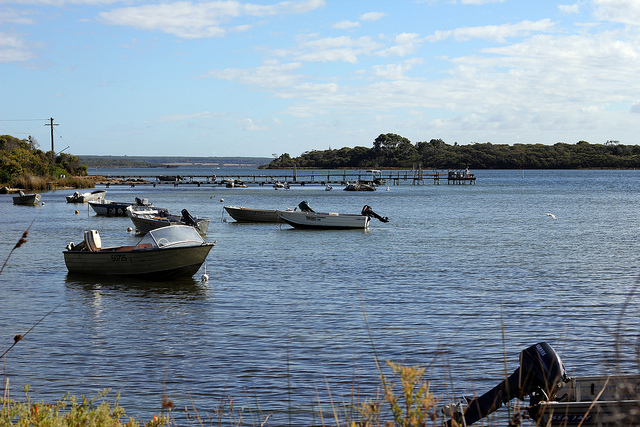Imagine a tale where this place is magical. In a hidden corner of the world, this lake was believed to be a portal to a magical realm. Legend had it that on certain nights, when the moon was full and the stars aligned just right, the waters would shimmer with an ethereal glow, and the boats would come to life. These enchanted vessels could traverse not just waters but realms, carrying those lucky enough to be aboard into lands of myth and wonder. The locals spoke of a brave young girl who once followed a mysterious light to the lake's edge, where she found an ancient boat waiting for her. As she stepped in, the boat glided effortlessly, taking her on an incredible journey through enchanted forests, sparkling cities of gold, and valleys inhabited by fantastical creatures. Every dawn, she would return with tales of her adventures, inspiring awe and wonder in the hearts of her listeners. The lake, with its tranquil demeanor by day and magical aura by night, became a symbol of endless possibilities and the extraordinary magic that lies just beyond the ordinary. 